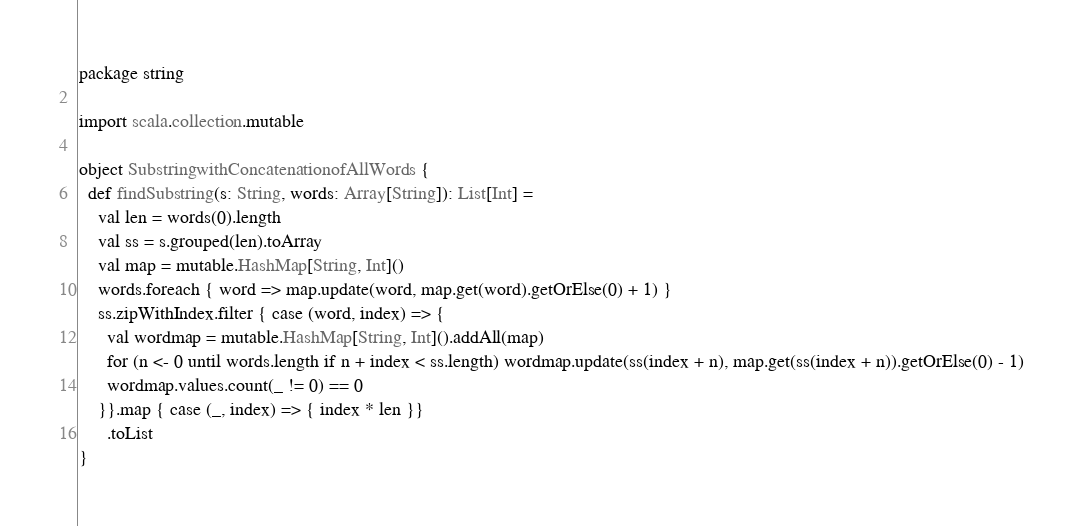Convert code to text. <code><loc_0><loc_0><loc_500><loc_500><_Scala_>package string

import scala.collection.mutable

object SubstringwithConcatenationofAllWords {
  def findSubstring(s: String, words: Array[String]): List[Int] =
    val len = words(0).length
    val ss = s.grouped(len).toArray
    val map = mutable.HashMap[String, Int]()
    words.foreach { word => map.update(word, map.get(word).getOrElse(0) + 1) }
    ss.zipWithIndex.filter { case (word, index) => {
      val wordmap = mutable.HashMap[String, Int]().addAll(map)
      for (n <- 0 until words.length if n + index < ss.length) wordmap.update(ss(index + n), map.get(ss(index + n)).getOrElse(0) - 1)
      wordmap.values.count(_ != 0) == 0
    }}.map { case (_, index) => { index * len }}
      .toList
}
</code> 